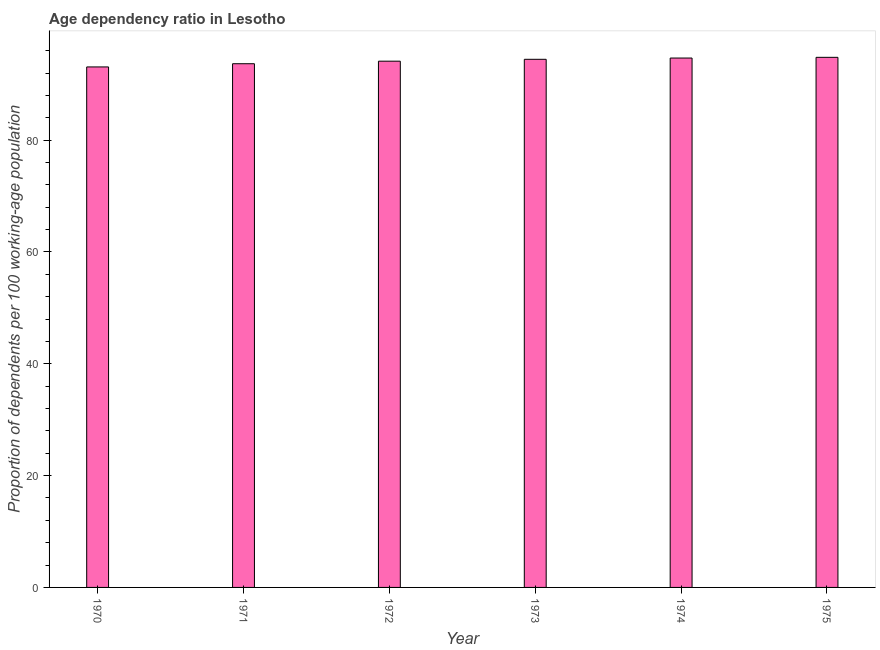Does the graph contain any zero values?
Provide a succinct answer. No. What is the title of the graph?
Ensure brevity in your answer.  Age dependency ratio in Lesotho. What is the label or title of the Y-axis?
Keep it short and to the point. Proportion of dependents per 100 working-age population. What is the age dependency ratio in 1970?
Offer a terse response. 93.09. Across all years, what is the maximum age dependency ratio?
Your answer should be compact. 94.8. Across all years, what is the minimum age dependency ratio?
Your response must be concise. 93.09. In which year was the age dependency ratio maximum?
Provide a succinct answer. 1975. In which year was the age dependency ratio minimum?
Provide a succinct answer. 1970. What is the sum of the age dependency ratio?
Ensure brevity in your answer.  564.79. What is the difference between the age dependency ratio in 1973 and 1974?
Make the answer very short. -0.23. What is the average age dependency ratio per year?
Ensure brevity in your answer.  94.13. What is the median age dependency ratio?
Offer a very short reply. 94.28. Is the difference between the age dependency ratio in 1970 and 1975 greater than the difference between any two years?
Your answer should be compact. Yes. What is the difference between the highest and the second highest age dependency ratio?
Provide a succinct answer. 0.13. What is the difference between the highest and the lowest age dependency ratio?
Make the answer very short. 1.72. In how many years, is the age dependency ratio greater than the average age dependency ratio taken over all years?
Make the answer very short. 3. How many bars are there?
Your response must be concise. 6. What is the Proportion of dependents per 100 working-age population of 1970?
Keep it short and to the point. 93.09. What is the Proportion of dependents per 100 working-age population of 1971?
Provide a short and direct response. 93.66. What is the Proportion of dependents per 100 working-age population in 1972?
Give a very brief answer. 94.11. What is the Proportion of dependents per 100 working-age population in 1973?
Ensure brevity in your answer.  94.45. What is the Proportion of dependents per 100 working-age population of 1974?
Your response must be concise. 94.68. What is the Proportion of dependents per 100 working-age population in 1975?
Your response must be concise. 94.8. What is the difference between the Proportion of dependents per 100 working-age population in 1970 and 1971?
Provide a succinct answer. -0.57. What is the difference between the Proportion of dependents per 100 working-age population in 1970 and 1972?
Offer a very short reply. -1.03. What is the difference between the Proportion of dependents per 100 working-age population in 1970 and 1973?
Ensure brevity in your answer.  -1.36. What is the difference between the Proportion of dependents per 100 working-age population in 1970 and 1974?
Offer a very short reply. -1.59. What is the difference between the Proportion of dependents per 100 working-age population in 1970 and 1975?
Offer a terse response. -1.72. What is the difference between the Proportion of dependents per 100 working-age population in 1971 and 1972?
Keep it short and to the point. -0.46. What is the difference between the Proportion of dependents per 100 working-age population in 1971 and 1973?
Ensure brevity in your answer.  -0.79. What is the difference between the Proportion of dependents per 100 working-age population in 1971 and 1974?
Make the answer very short. -1.02. What is the difference between the Proportion of dependents per 100 working-age population in 1971 and 1975?
Offer a very short reply. -1.14. What is the difference between the Proportion of dependents per 100 working-age population in 1972 and 1973?
Provide a succinct answer. -0.34. What is the difference between the Proportion of dependents per 100 working-age population in 1972 and 1974?
Your response must be concise. -0.56. What is the difference between the Proportion of dependents per 100 working-age population in 1972 and 1975?
Make the answer very short. -0.69. What is the difference between the Proportion of dependents per 100 working-age population in 1973 and 1974?
Your response must be concise. -0.23. What is the difference between the Proportion of dependents per 100 working-age population in 1973 and 1975?
Offer a very short reply. -0.35. What is the difference between the Proportion of dependents per 100 working-age population in 1974 and 1975?
Ensure brevity in your answer.  -0.13. What is the ratio of the Proportion of dependents per 100 working-age population in 1970 to that in 1971?
Offer a terse response. 0.99. What is the ratio of the Proportion of dependents per 100 working-age population in 1970 to that in 1975?
Give a very brief answer. 0.98. What is the ratio of the Proportion of dependents per 100 working-age population in 1971 to that in 1972?
Provide a succinct answer. 0.99. What is the ratio of the Proportion of dependents per 100 working-age population in 1972 to that in 1975?
Ensure brevity in your answer.  0.99. What is the ratio of the Proportion of dependents per 100 working-age population in 1973 to that in 1974?
Provide a succinct answer. 1. What is the ratio of the Proportion of dependents per 100 working-age population in 1973 to that in 1975?
Your answer should be very brief. 1. What is the ratio of the Proportion of dependents per 100 working-age population in 1974 to that in 1975?
Provide a succinct answer. 1. 